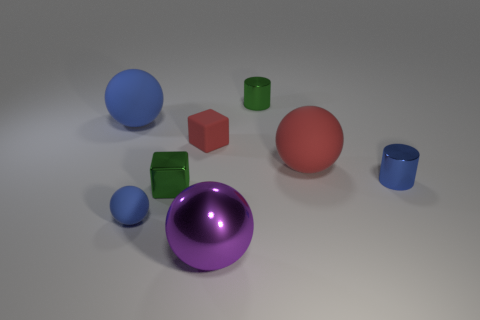There is a shiny object to the right of the green cylinder to the right of the large thing behind the tiny red cube; what size is it?
Ensure brevity in your answer.  Small. There is a green metal thing behind the blue rubber thing on the left side of the tiny sphere; what shape is it?
Offer a very short reply. Cylinder. There is a tiny cylinder behind the small blue cylinder; does it have the same color as the tiny shiny cube?
Make the answer very short. Yes. There is a ball that is on the left side of the tiny red matte object and behind the blue cylinder; what is its color?
Your answer should be very brief. Blue. Is there a small green cube that has the same material as the blue cylinder?
Offer a terse response. Yes. What size is the green block?
Offer a very short reply. Small. How big is the matte sphere that is in front of the big rubber sphere in front of the small red block?
Your response must be concise. Small. There is another object that is the same shape as the tiny blue metal thing; what material is it?
Provide a succinct answer. Metal. How many cubes are there?
Make the answer very short. 2. The tiny metal thing that is left of the small object behind the blue matte thing that is behind the tiny ball is what color?
Your response must be concise. Green. 